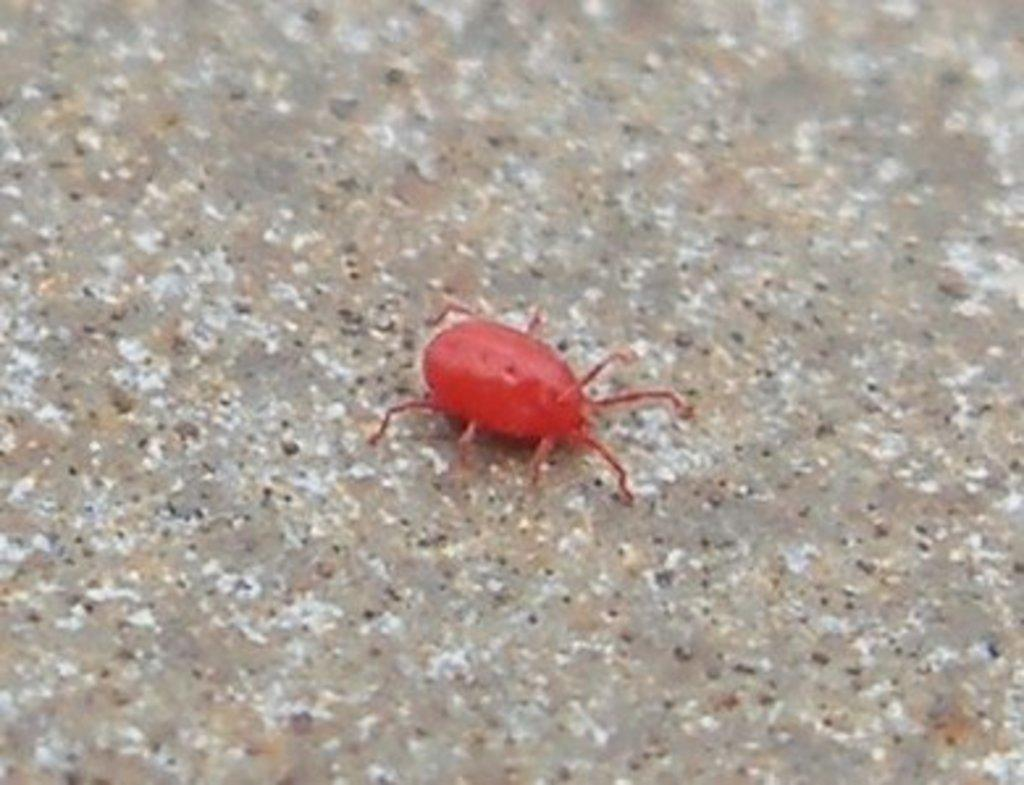What type of creature is in the image? There is an insect in the image. What color is the insect? The insect is red in color. What colors are present on the surface where the insect is located? The surface has ash, brown, and white colors. How much blood does the insect have in the image? There is no indication of blood in the image, and insects do not have blood like humans or other animals. 